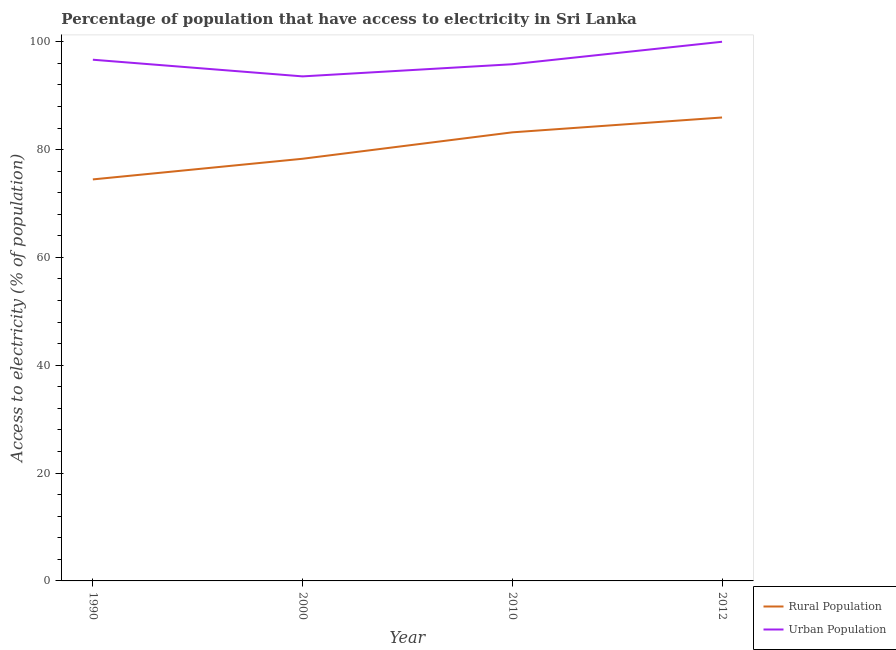How many different coloured lines are there?
Your response must be concise. 2. Is the number of lines equal to the number of legend labels?
Ensure brevity in your answer.  Yes. What is the percentage of rural population having access to electricity in 2010?
Provide a short and direct response. 83.2. Across all years, what is the maximum percentage of urban population having access to electricity?
Provide a short and direct response. 100. Across all years, what is the minimum percentage of rural population having access to electricity?
Make the answer very short. 74.47. In which year was the percentage of urban population having access to electricity maximum?
Offer a very short reply. 2012. In which year was the percentage of urban population having access to electricity minimum?
Give a very brief answer. 2000. What is the total percentage of urban population having access to electricity in the graph?
Provide a short and direct response. 386.08. What is the difference between the percentage of rural population having access to electricity in 2000 and that in 2010?
Provide a short and direct response. -4.9. What is the difference between the percentage of urban population having access to electricity in 2000 and the percentage of rural population having access to electricity in 2012?
Your answer should be compact. 7.62. What is the average percentage of urban population having access to electricity per year?
Keep it short and to the point. 96.52. In the year 2010, what is the difference between the percentage of urban population having access to electricity and percentage of rural population having access to electricity?
Provide a succinct answer. 12.63. In how many years, is the percentage of urban population having access to electricity greater than 28 %?
Give a very brief answer. 4. What is the ratio of the percentage of rural population having access to electricity in 1990 to that in 2010?
Offer a terse response. 0.9. Is the percentage of rural population having access to electricity in 1990 less than that in 2012?
Your answer should be very brief. Yes. Is the difference between the percentage of rural population having access to electricity in 2000 and 2012 greater than the difference between the percentage of urban population having access to electricity in 2000 and 2012?
Offer a very short reply. No. What is the difference between the highest and the second highest percentage of rural population having access to electricity?
Make the answer very short. 2.75. What is the difference between the highest and the lowest percentage of urban population having access to electricity?
Provide a short and direct response. 6.42. Is the sum of the percentage of rural population having access to electricity in 1990 and 2000 greater than the maximum percentage of urban population having access to electricity across all years?
Your response must be concise. Yes. Does the percentage of urban population having access to electricity monotonically increase over the years?
Your answer should be compact. No. How many lines are there?
Your answer should be compact. 2. What is the difference between two consecutive major ticks on the Y-axis?
Offer a terse response. 20. Does the graph contain any zero values?
Give a very brief answer. No. Where does the legend appear in the graph?
Your answer should be compact. Bottom right. What is the title of the graph?
Your answer should be compact. Percentage of population that have access to electricity in Sri Lanka. What is the label or title of the Y-axis?
Give a very brief answer. Access to electricity (% of population). What is the Access to electricity (% of population) of Rural Population in 1990?
Ensure brevity in your answer.  74.47. What is the Access to electricity (% of population) in Urban Population in 1990?
Provide a short and direct response. 96.67. What is the Access to electricity (% of population) in Rural Population in 2000?
Your answer should be compact. 78.3. What is the Access to electricity (% of population) in Urban Population in 2000?
Keep it short and to the point. 93.58. What is the Access to electricity (% of population) in Rural Population in 2010?
Make the answer very short. 83.2. What is the Access to electricity (% of population) of Urban Population in 2010?
Ensure brevity in your answer.  95.83. What is the Access to electricity (% of population) in Rural Population in 2012?
Make the answer very short. 85.95. What is the Access to electricity (% of population) in Urban Population in 2012?
Provide a succinct answer. 100. Across all years, what is the maximum Access to electricity (% of population) in Rural Population?
Keep it short and to the point. 85.95. Across all years, what is the maximum Access to electricity (% of population) in Urban Population?
Ensure brevity in your answer.  100. Across all years, what is the minimum Access to electricity (% of population) in Rural Population?
Your response must be concise. 74.47. Across all years, what is the minimum Access to electricity (% of population) in Urban Population?
Ensure brevity in your answer.  93.58. What is the total Access to electricity (% of population) of Rural Population in the graph?
Provide a short and direct response. 321.92. What is the total Access to electricity (% of population) in Urban Population in the graph?
Make the answer very short. 386.08. What is the difference between the Access to electricity (% of population) of Rural Population in 1990 and that in 2000?
Offer a terse response. -3.83. What is the difference between the Access to electricity (% of population) in Urban Population in 1990 and that in 2000?
Offer a very short reply. 3.09. What is the difference between the Access to electricity (% of population) in Rural Population in 1990 and that in 2010?
Keep it short and to the point. -8.73. What is the difference between the Access to electricity (% of population) in Urban Population in 1990 and that in 2010?
Provide a short and direct response. 0.84. What is the difference between the Access to electricity (% of population) in Rural Population in 1990 and that in 2012?
Keep it short and to the point. -11.48. What is the difference between the Access to electricity (% of population) of Urban Population in 1990 and that in 2012?
Your response must be concise. -3.33. What is the difference between the Access to electricity (% of population) in Urban Population in 2000 and that in 2010?
Your response must be concise. -2.25. What is the difference between the Access to electricity (% of population) in Rural Population in 2000 and that in 2012?
Provide a succinct answer. -7.65. What is the difference between the Access to electricity (% of population) in Urban Population in 2000 and that in 2012?
Your answer should be compact. -6.42. What is the difference between the Access to electricity (% of population) in Rural Population in 2010 and that in 2012?
Offer a terse response. -2.75. What is the difference between the Access to electricity (% of population) of Urban Population in 2010 and that in 2012?
Your answer should be very brief. -4.17. What is the difference between the Access to electricity (% of population) of Rural Population in 1990 and the Access to electricity (% of population) of Urban Population in 2000?
Make the answer very short. -19.11. What is the difference between the Access to electricity (% of population) of Rural Population in 1990 and the Access to electricity (% of population) of Urban Population in 2010?
Provide a succinct answer. -21.36. What is the difference between the Access to electricity (% of population) of Rural Population in 1990 and the Access to electricity (% of population) of Urban Population in 2012?
Offer a very short reply. -25.53. What is the difference between the Access to electricity (% of population) in Rural Population in 2000 and the Access to electricity (% of population) in Urban Population in 2010?
Ensure brevity in your answer.  -17.53. What is the difference between the Access to electricity (% of population) of Rural Population in 2000 and the Access to electricity (% of population) of Urban Population in 2012?
Your answer should be very brief. -21.7. What is the difference between the Access to electricity (% of population) of Rural Population in 2010 and the Access to electricity (% of population) of Urban Population in 2012?
Offer a terse response. -16.8. What is the average Access to electricity (% of population) in Rural Population per year?
Give a very brief answer. 80.48. What is the average Access to electricity (% of population) of Urban Population per year?
Provide a succinct answer. 96.52. In the year 1990, what is the difference between the Access to electricity (% of population) in Rural Population and Access to electricity (% of population) in Urban Population?
Your response must be concise. -22.2. In the year 2000, what is the difference between the Access to electricity (% of population) of Rural Population and Access to electricity (% of population) of Urban Population?
Give a very brief answer. -15.28. In the year 2010, what is the difference between the Access to electricity (% of population) in Rural Population and Access to electricity (% of population) in Urban Population?
Ensure brevity in your answer.  -12.63. In the year 2012, what is the difference between the Access to electricity (% of population) in Rural Population and Access to electricity (% of population) in Urban Population?
Keep it short and to the point. -14.05. What is the ratio of the Access to electricity (% of population) in Rural Population in 1990 to that in 2000?
Make the answer very short. 0.95. What is the ratio of the Access to electricity (% of population) in Urban Population in 1990 to that in 2000?
Provide a short and direct response. 1.03. What is the ratio of the Access to electricity (% of population) in Rural Population in 1990 to that in 2010?
Make the answer very short. 0.9. What is the ratio of the Access to electricity (% of population) of Urban Population in 1990 to that in 2010?
Your response must be concise. 1.01. What is the ratio of the Access to electricity (% of population) of Rural Population in 1990 to that in 2012?
Provide a short and direct response. 0.87. What is the ratio of the Access to electricity (% of population) of Urban Population in 1990 to that in 2012?
Your response must be concise. 0.97. What is the ratio of the Access to electricity (% of population) in Rural Population in 2000 to that in 2010?
Keep it short and to the point. 0.94. What is the ratio of the Access to electricity (% of population) in Urban Population in 2000 to that in 2010?
Give a very brief answer. 0.98. What is the ratio of the Access to electricity (% of population) in Rural Population in 2000 to that in 2012?
Provide a short and direct response. 0.91. What is the ratio of the Access to electricity (% of population) in Urban Population in 2000 to that in 2012?
Ensure brevity in your answer.  0.94. What is the ratio of the Access to electricity (% of population) of Rural Population in 2010 to that in 2012?
Provide a succinct answer. 0.97. What is the ratio of the Access to electricity (% of population) in Urban Population in 2010 to that in 2012?
Provide a succinct answer. 0.96. What is the difference between the highest and the second highest Access to electricity (% of population) of Rural Population?
Provide a short and direct response. 2.75. What is the difference between the highest and the second highest Access to electricity (% of population) of Urban Population?
Provide a succinct answer. 3.33. What is the difference between the highest and the lowest Access to electricity (% of population) in Rural Population?
Your answer should be very brief. 11.48. What is the difference between the highest and the lowest Access to electricity (% of population) in Urban Population?
Your response must be concise. 6.42. 